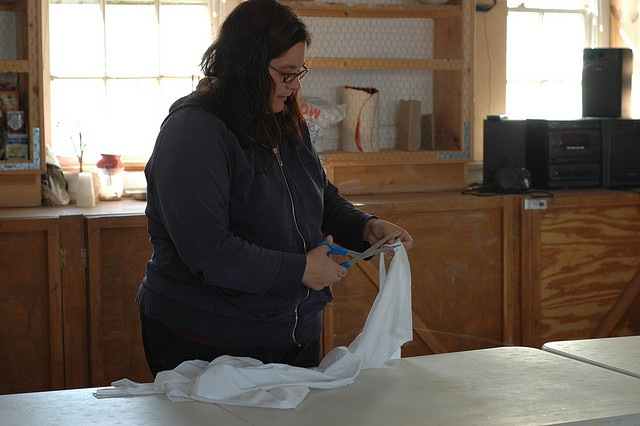Describe the objects in this image and their specific colors. I can see people in black, gray, and maroon tones, dining table in black, darkgray, gray, and lightblue tones, dining table in black, darkgray, beige, lightgray, and gray tones, vase in black, ivory, brown, and tan tones, and scissors in black, gray, navy, and maroon tones in this image. 